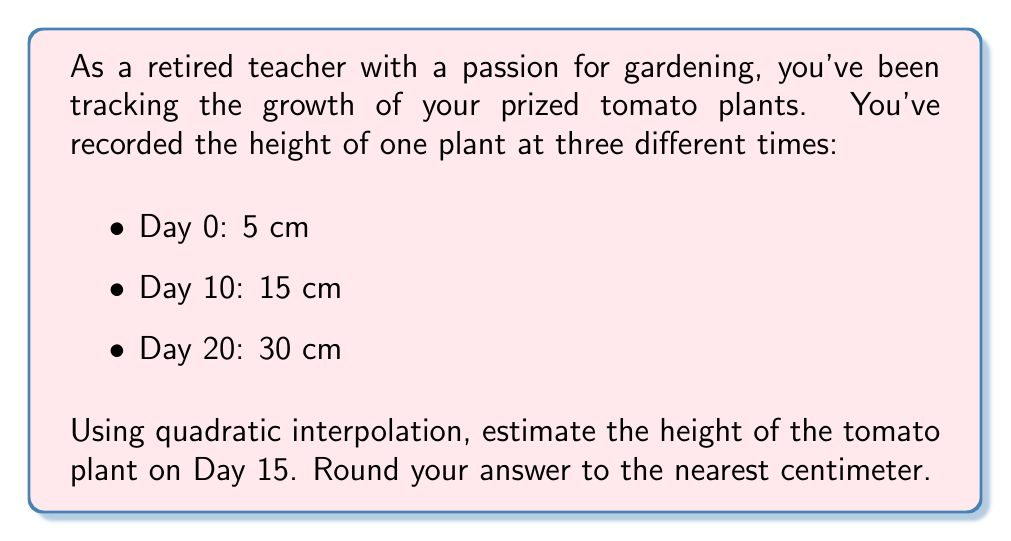What is the answer to this math problem? To solve this problem, we'll use Lagrange interpolation with a quadratic polynomial. The general form of the quadratic Lagrange interpolation polynomial is:

$$P(x) = y_0L_0(x) + y_1L_1(x) + y_2L_2(x)$$

Where:

$$L_0(x) = \frac{(x-x_1)(x-x_2)}{(x_0-x_1)(x_0-x_2)}$$

$$L_1(x) = \frac{(x-x_0)(x-x_2)}{(x_1-x_0)(x_1-x_2)}$$

$$L_2(x) = \frac{(x-x_0)(x-x_1)}{(x_2-x_0)(x_2-x_1)}$$

Given data:
$(x_0, y_0) = (0, 5)$
$(x_1, y_1) = (10, 15)$
$(x_2, y_2) = (20, 30)$

We want to find $P(15)$.

Step 1: Calculate $L_0(15)$, $L_1(15)$, and $L_2(15)$

$$L_0(15) = \frac{(15-10)(15-20)}{(0-10)(0-20)} = \frac{5(-5)}{(-10)(-20)} = \frac{-25}{200} = -0.125$$

$$L_1(15) = \frac{(15-0)(15-20)}{(10-0)(10-20)} = \frac{15(-5)}{10(-10)} = \frac{-75}{-100} = 0.75$$

$$L_2(15) = \frac{(15-0)(15-10)}{(20-0)(20-10)} = \frac{15(5)}{20(10)} = \frac{75}{200} = 0.375$$

Step 2: Apply the Lagrange interpolation formula

$$P(15) = 5L_0(15) + 15L_1(15) + 30L_2(15)$$

$$P(15) = 5(-0.125) + 15(0.75) + 30(0.375)$$

$$P(15) = -0.625 + 11.25 + 11.25$$

$$P(15) = 21.875$$

Step 3: Round to the nearest centimeter

$21.875$ rounded to the nearest centimeter is 22 cm.
Answer: 22 cm 